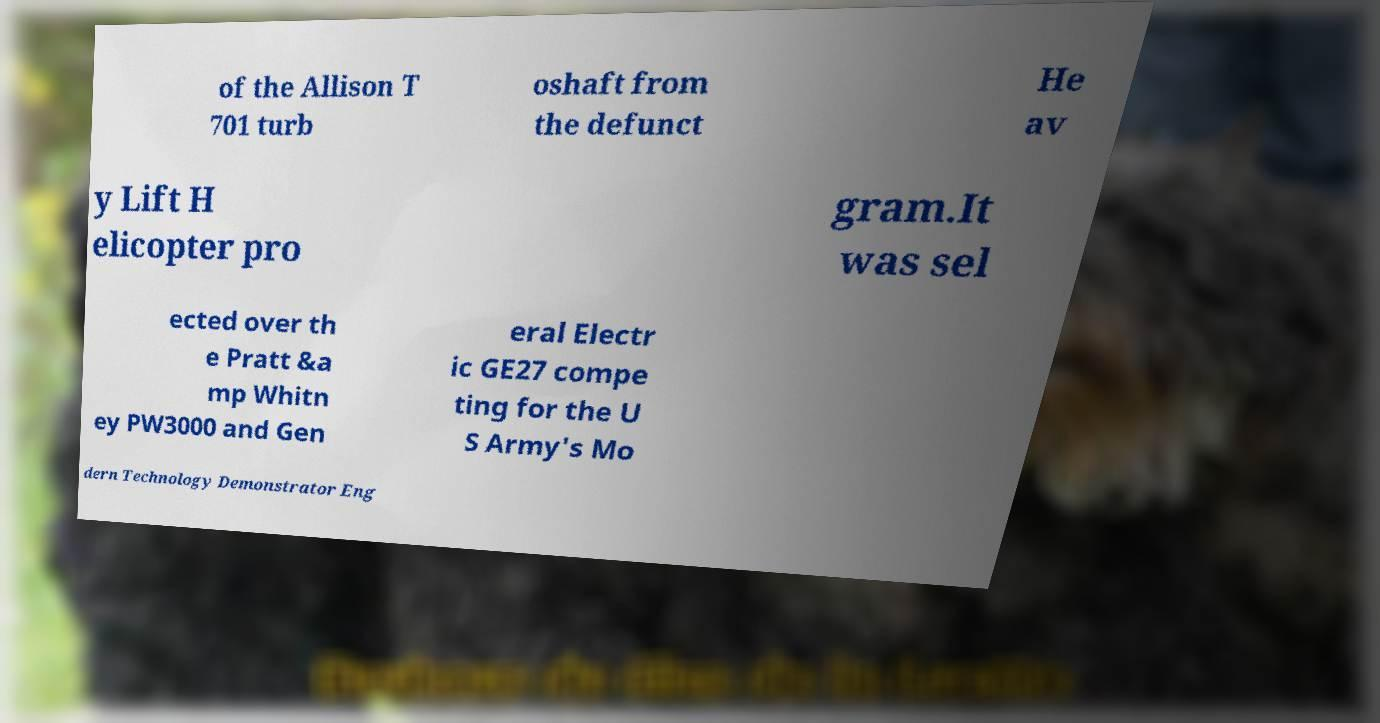For documentation purposes, I need the text within this image transcribed. Could you provide that? of the Allison T 701 turb oshaft from the defunct He av y Lift H elicopter pro gram.It was sel ected over th e Pratt &a mp Whitn ey PW3000 and Gen eral Electr ic GE27 compe ting for the U S Army's Mo dern Technology Demonstrator Eng 